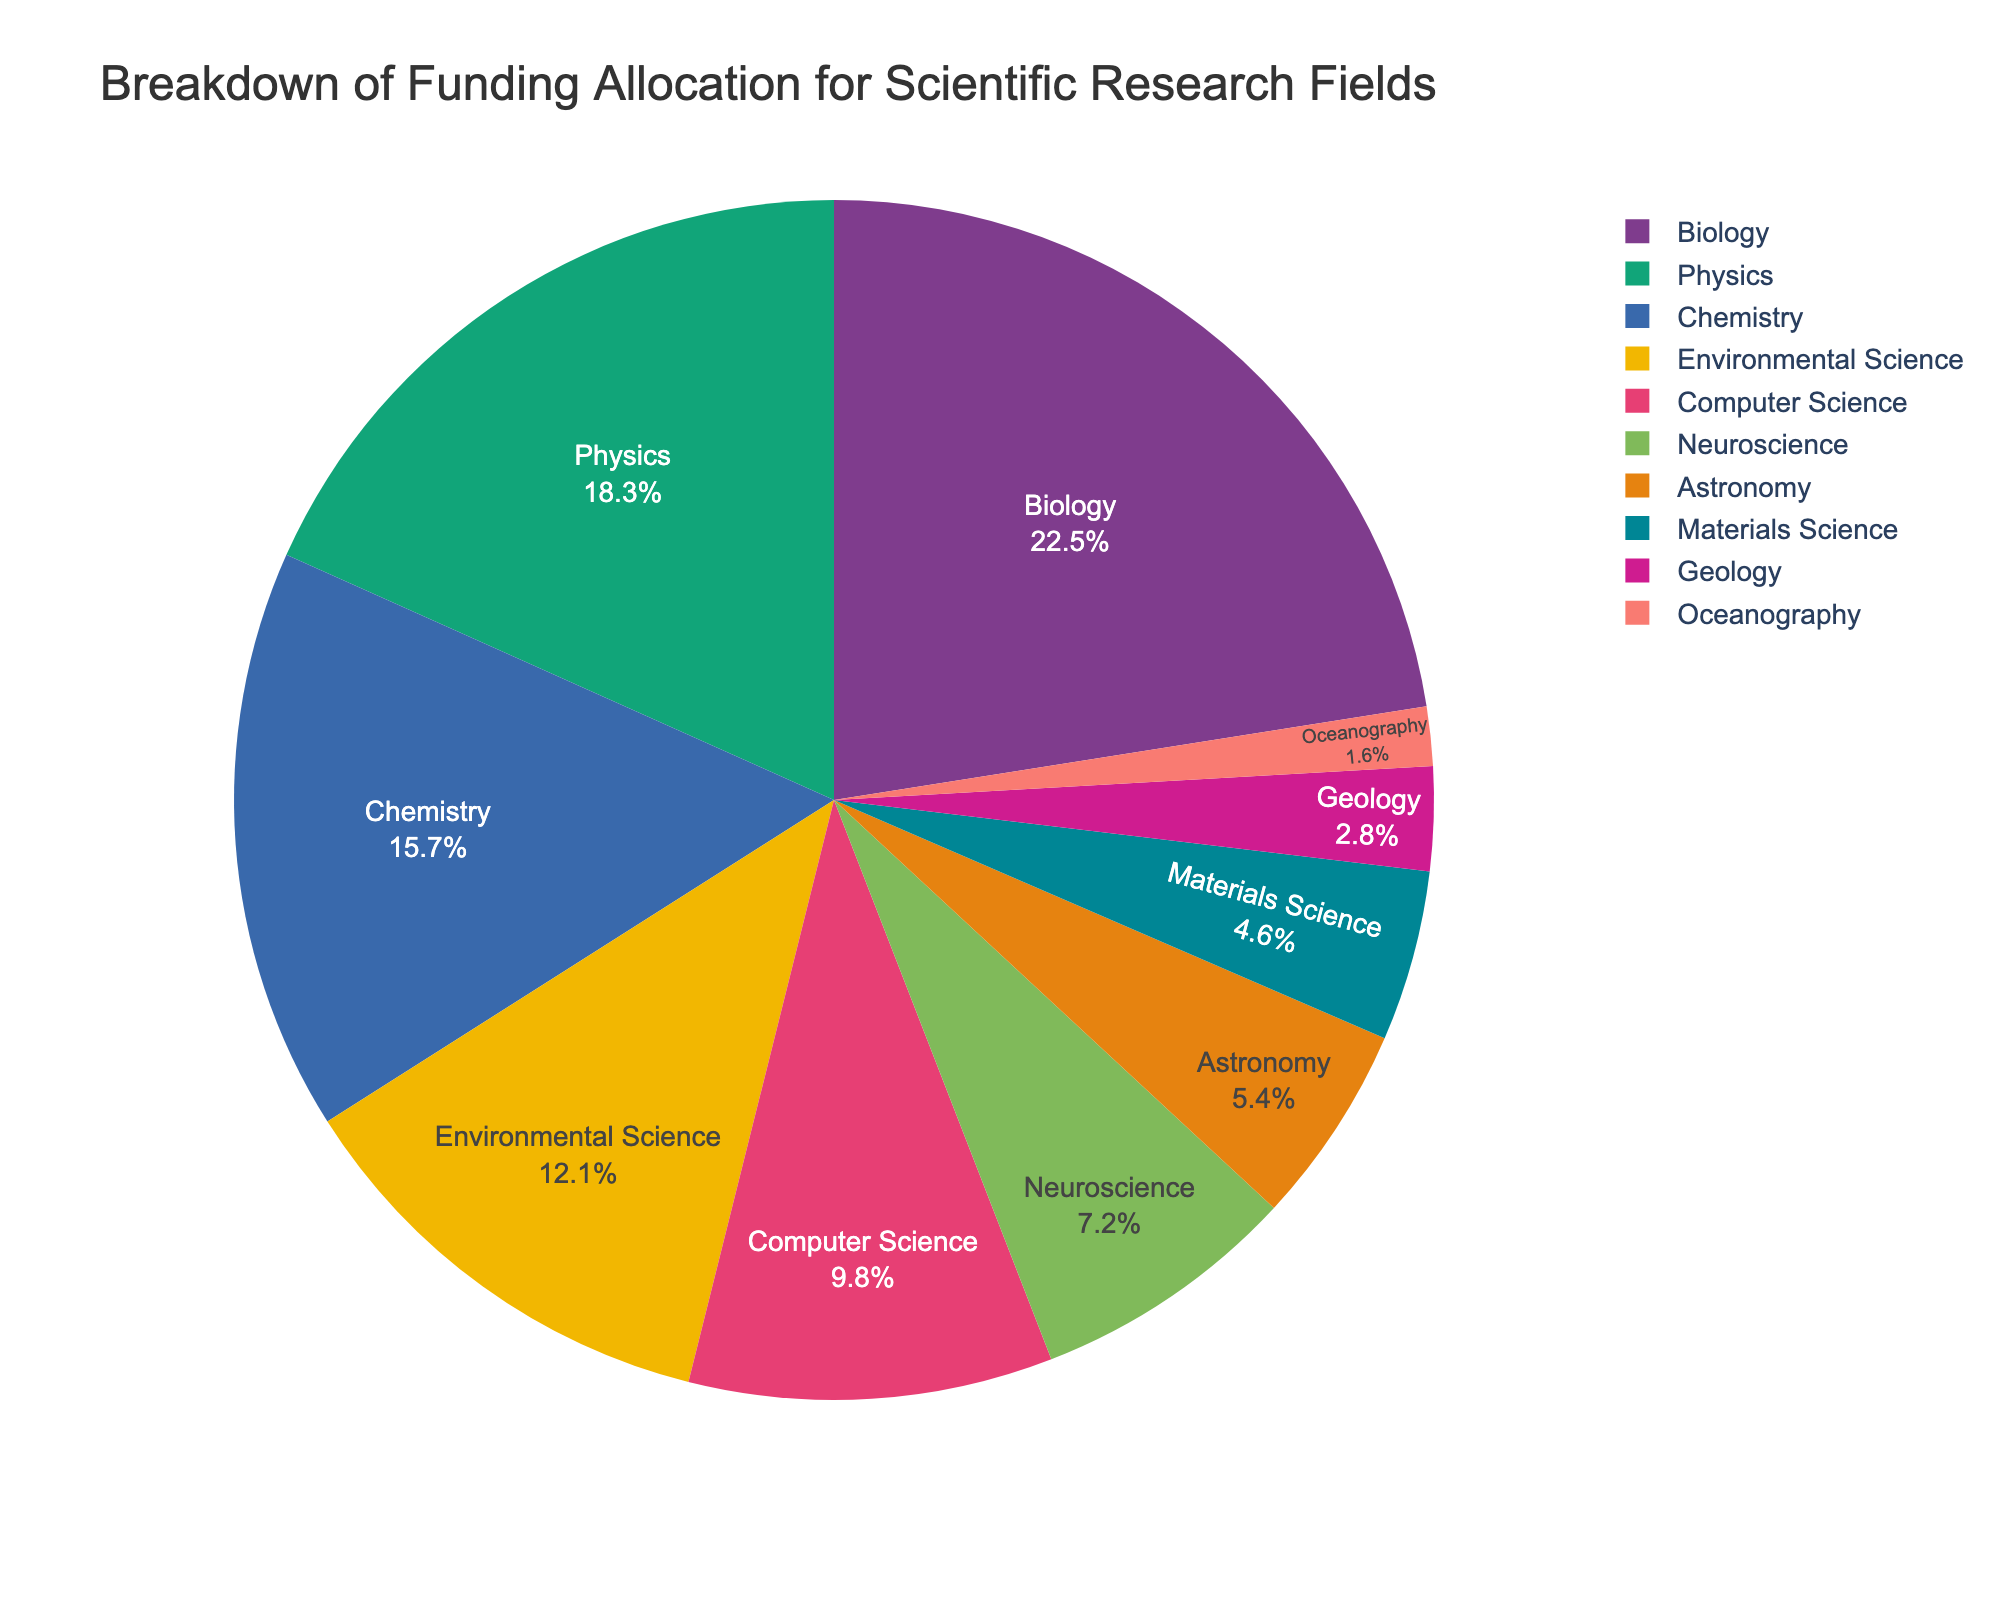Which scientific research field receives the most funding? We can observe from the pie chart that the slice labeled "Biology" is the largest. Biology has the highest funding percentage.
Answer: Biology How much more funding does Biology receive compared to Geology? From the pie chart, Biology receives 22.5% and Geology receives 2.8%. The difference can be calculated as 22.5% - 2.8% = 19.7%.
Answer: 19.7% Which field among Chemistry, Computer Science, and Oceanography receives the least funding? By looking at the pie chart and comparing the sizes of the slices labeled Chemistry, Computer Science, and Oceanography, it's evident that the Oceanography slice is the smallest.
Answer: Oceanography What percentage of the total funding is allocated to Physics and Chemistry combined? Physics has 18.3% funding and Chemistry has 15.7%. Adding them gives 18.3% + 15.7% = 34%.
Answer: 34% Is the funding allocation for Environmental Science greater than that for Neuroscience? By comparing the sizes of the slices for Environmental Science (12.1%) and Neuroscience (7.2%), it is clear that Environmental Science has a larger share.
Answer: Yes Rank the top three fields with the highest funding allocation. The pie chart shows that the largest slices correspond to Biology (22.5%), Physics (18.3%), and Chemistry (15.7%) in descending order.
Answer: Biology, Physics, Chemistry What is the average funding percentage for the three fields with the smallest allocations? The fields with the smallest allocations are Oceanography (1.6%), Geology (2.8%), and Materials Science (4.6%). The average can be calculated as (1.6 + 2.8 + 4.6) / 3 = 3%.
Answer: 3% What fraction of the funding is allocated to Astronomy and Oceanography together? Astronomy has 5.4% and Oceanography has 1.6%. Adding these gives 5.4% + 1.6% = 7%. As a fraction of the total funding (100%), this is 7/100 or 7%.
Answer: 7% If the funding for Computer Science and Neuroscience were combined, would it exceed that of Physics? The funding for Computer Science is 9.8% and Neuroscience is 7.2%. Combined, they sum to 9.8% + 7.2% = 17%. Since Physics receives 18.3%, 17% is less than 18.3%.
Answer: No Which field has a funding allocation closest to 10%? The slice for Computer Science shows a funding allocation of 9.8%, which is closest to 10%.
Answer: Computer Science 